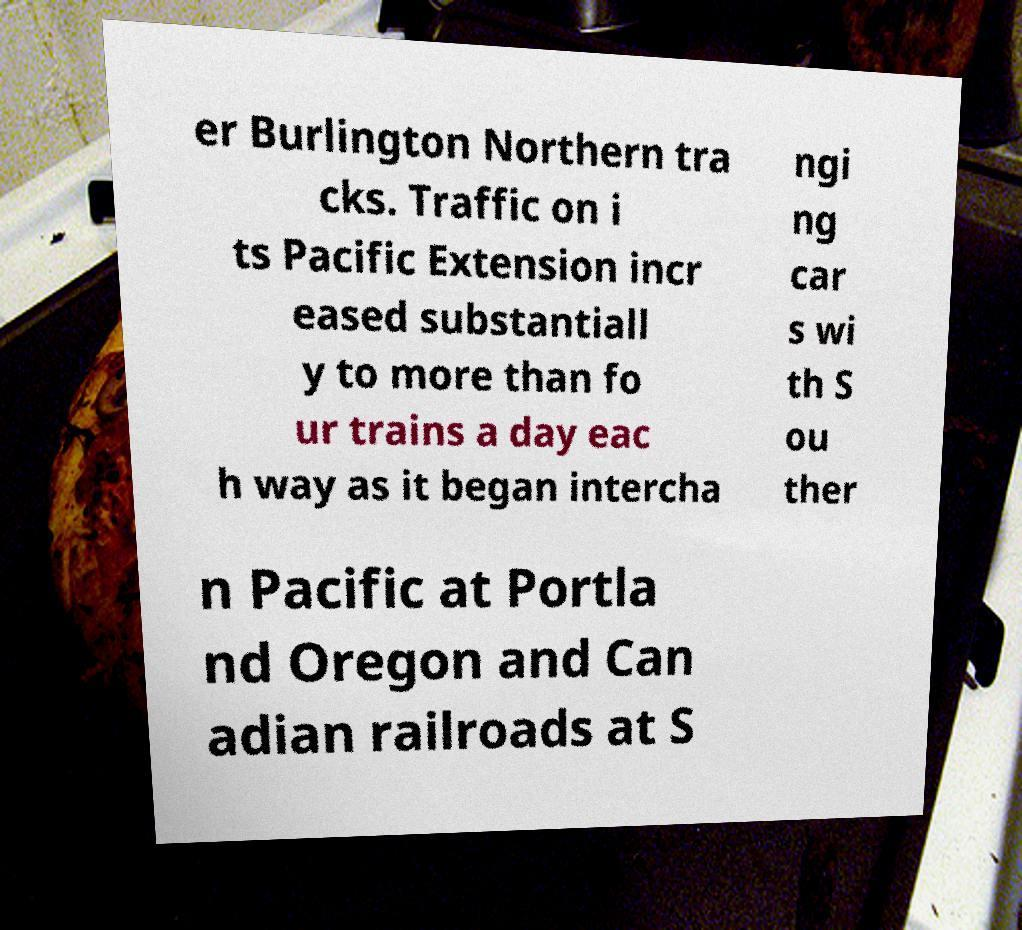For documentation purposes, I need the text within this image transcribed. Could you provide that? er Burlington Northern tra cks. Traffic on i ts Pacific Extension incr eased substantiall y to more than fo ur trains a day eac h way as it began intercha ngi ng car s wi th S ou ther n Pacific at Portla nd Oregon and Can adian railroads at S 